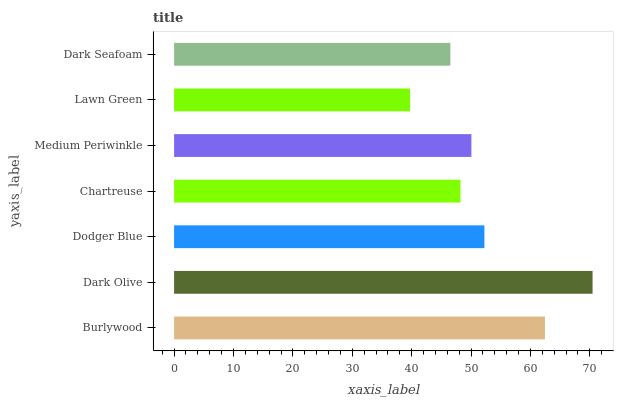Is Lawn Green the minimum?
Answer yes or no. Yes. Is Dark Olive the maximum?
Answer yes or no. Yes. Is Dodger Blue the minimum?
Answer yes or no. No. Is Dodger Blue the maximum?
Answer yes or no. No. Is Dark Olive greater than Dodger Blue?
Answer yes or no. Yes. Is Dodger Blue less than Dark Olive?
Answer yes or no. Yes. Is Dodger Blue greater than Dark Olive?
Answer yes or no. No. Is Dark Olive less than Dodger Blue?
Answer yes or no. No. Is Medium Periwinkle the high median?
Answer yes or no. Yes. Is Medium Periwinkle the low median?
Answer yes or no. Yes. Is Dark Olive the high median?
Answer yes or no. No. Is Lawn Green the low median?
Answer yes or no. No. 